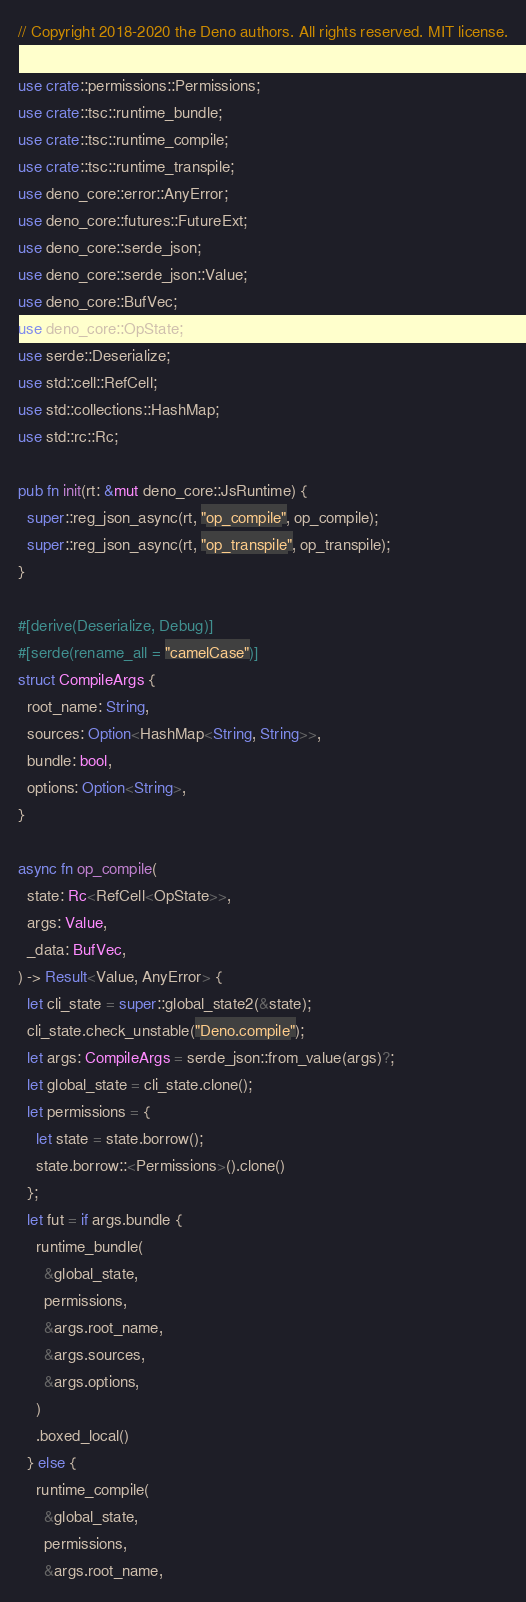<code> <loc_0><loc_0><loc_500><loc_500><_Rust_>// Copyright 2018-2020 the Deno authors. All rights reserved. MIT license.

use crate::permissions::Permissions;
use crate::tsc::runtime_bundle;
use crate::tsc::runtime_compile;
use crate::tsc::runtime_transpile;
use deno_core::error::AnyError;
use deno_core::futures::FutureExt;
use deno_core::serde_json;
use deno_core::serde_json::Value;
use deno_core::BufVec;
use deno_core::OpState;
use serde::Deserialize;
use std::cell::RefCell;
use std::collections::HashMap;
use std::rc::Rc;

pub fn init(rt: &mut deno_core::JsRuntime) {
  super::reg_json_async(rt, "op_compile", op_compile);
  super::reg_json_async(rt, "op_transpile", op_transpile);
}

#[derive(Deserialize, Debug)]
#[serde(rename_all = "camelCase")]
struct CompileArgs {
  root_name: String,
  sources: Option<HashMap<String, String>>,
  bundle: bool,
  options: Option<String>,
}

async fn op_compile(
  state: Rc<RefCell<OpState>>,
  args: Value,
  _data: BufVec,
) -> Result<Value, AnyError> {
  let cli_state = super::global_state2(&state);
  cli_state.check_unstable("Deno.compile");
  let args: CompileArgs = serde_json::from_value(args)?;
  let global_state = cli_state.clone();
  let permissions = {
    let state = state.borrow();
    state.borrow::<Permissions>().clone()
  };
  let fut = if args.bundle {
    runtime_bundle(
      &global_state,
      permissions,
      &args.root_name,
      &args.sources,
      &args.options,
    )
    .boxed_local()
  } else {
    runtime_compile(
      &global_state,
      permissions,
      &args.root_name,</code> 